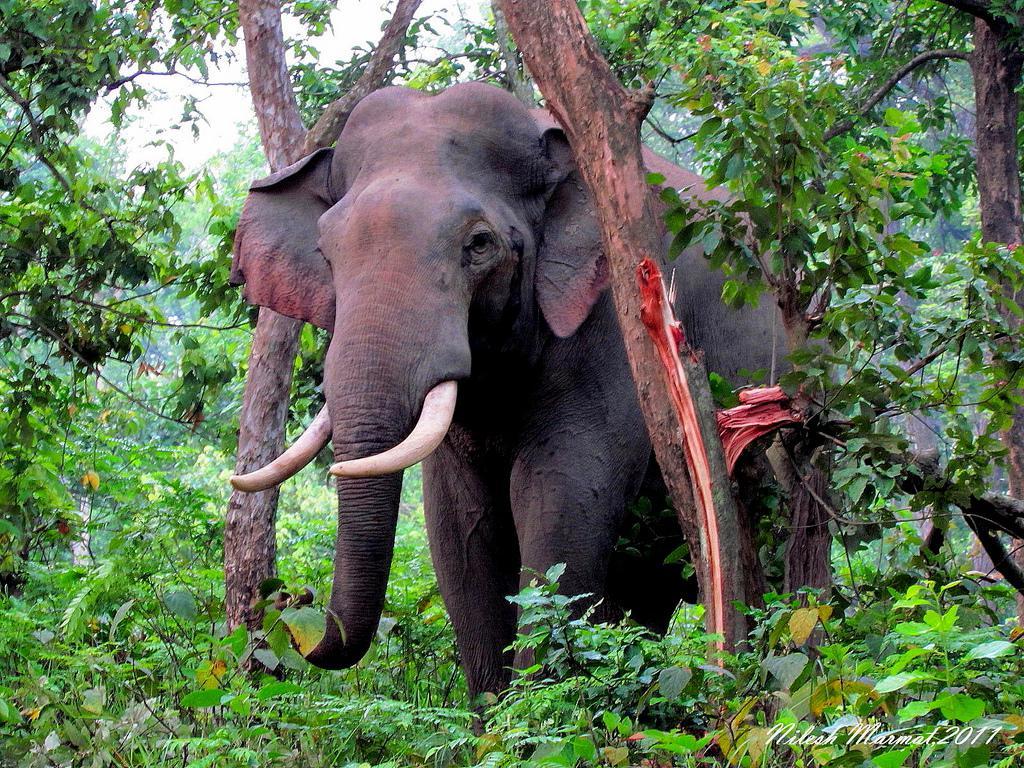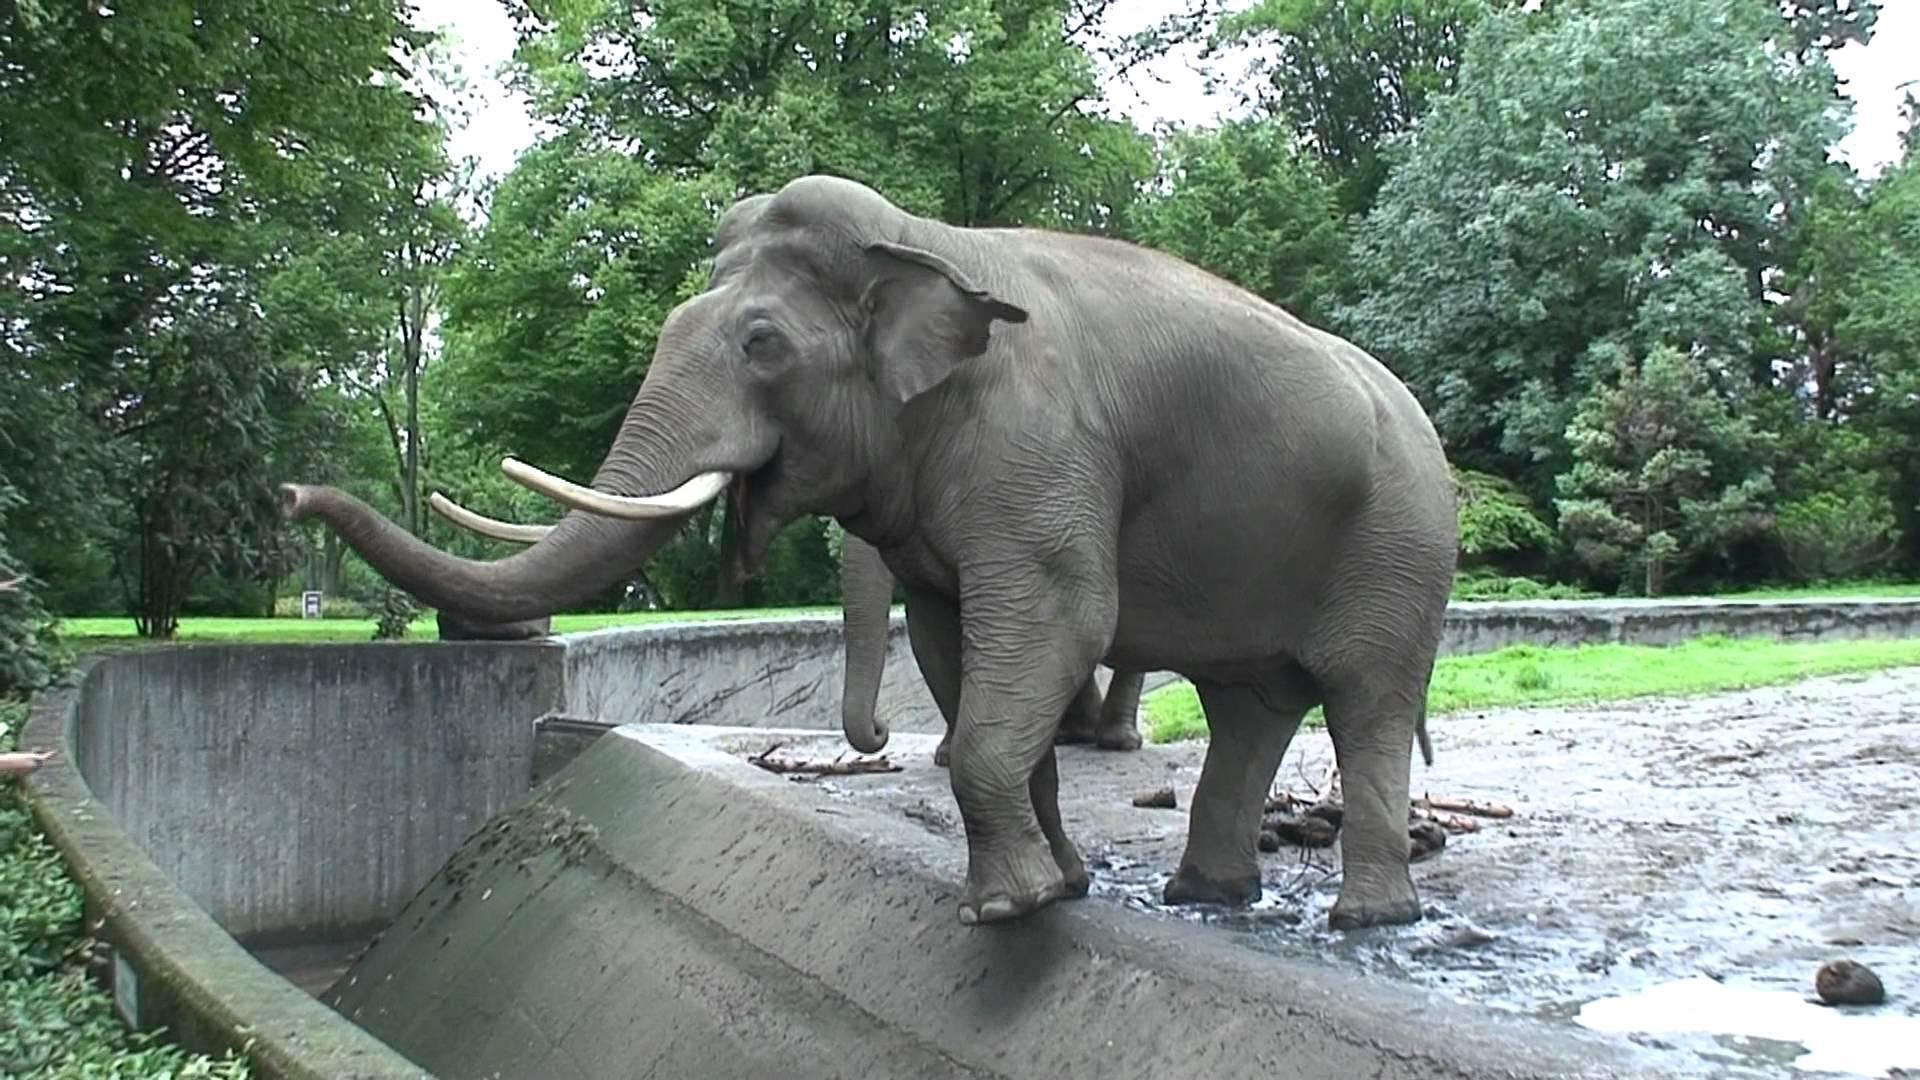The first image is the image on the left, the second image is the image on the right. Examine the images to the left and right. Is the description "There are elephants near a body of water." accurate? Answer yes or no. No. The first image is the image on the left, the second image is the image on the right. Assess this claim about the two images: "The elephant in the image on the left are standing in a grassy wooded area.". Correct or not? Answer yes or no. Yes. 